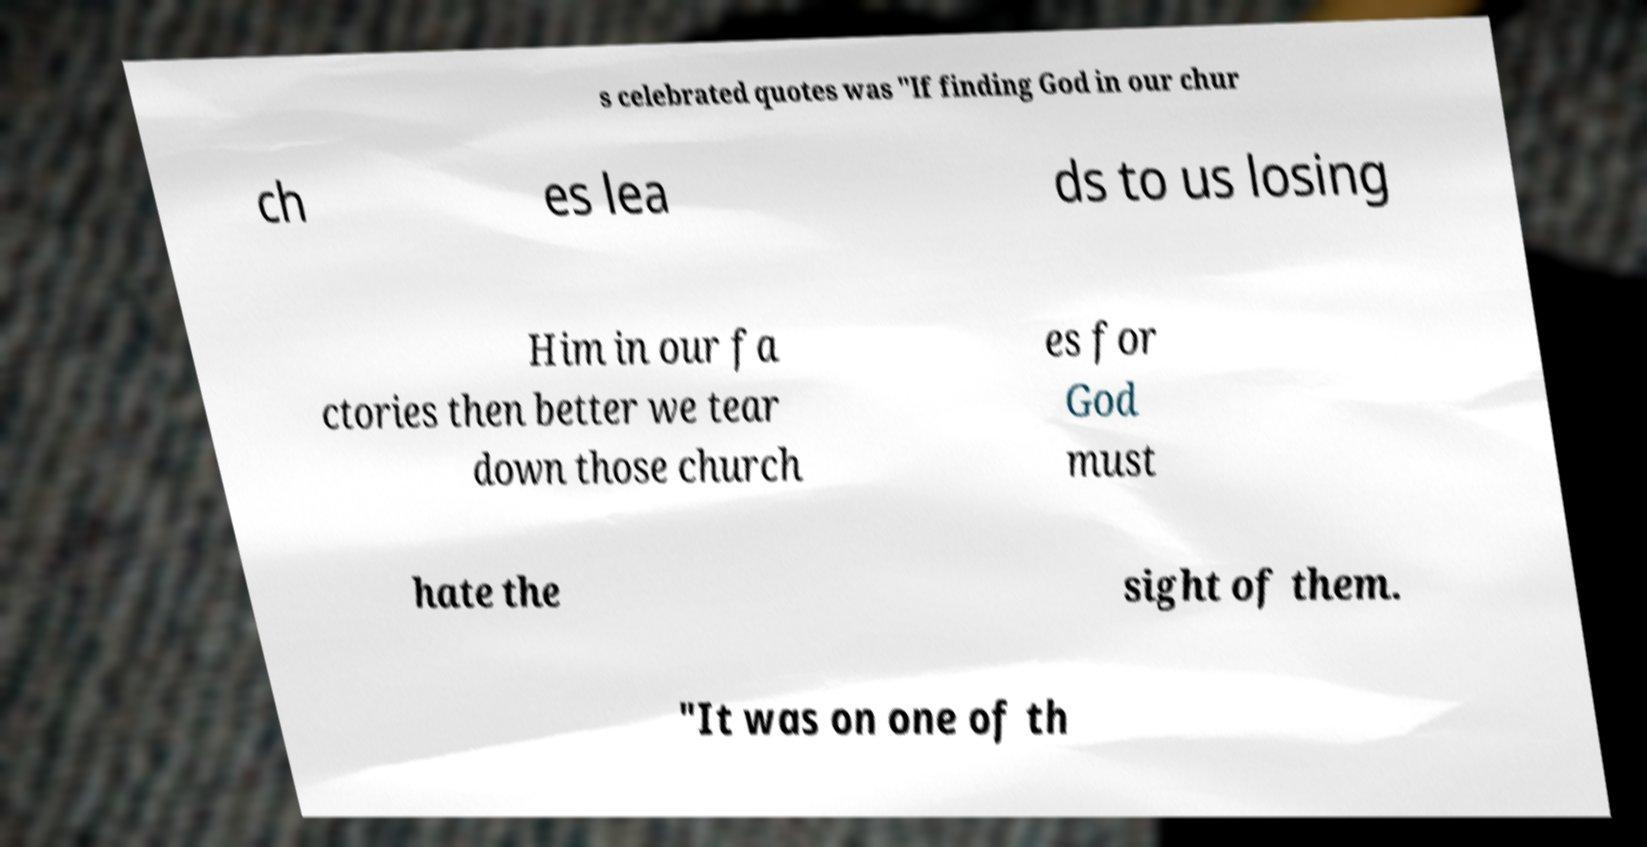I need the written content from this picture converted into text. Can you do that? s celebrated quotes was "If finding God in our chur ch es lea ds to us losing Him in our fa ctories then better we tear down those church es for God must hate the sight of them. "It was on one of th 